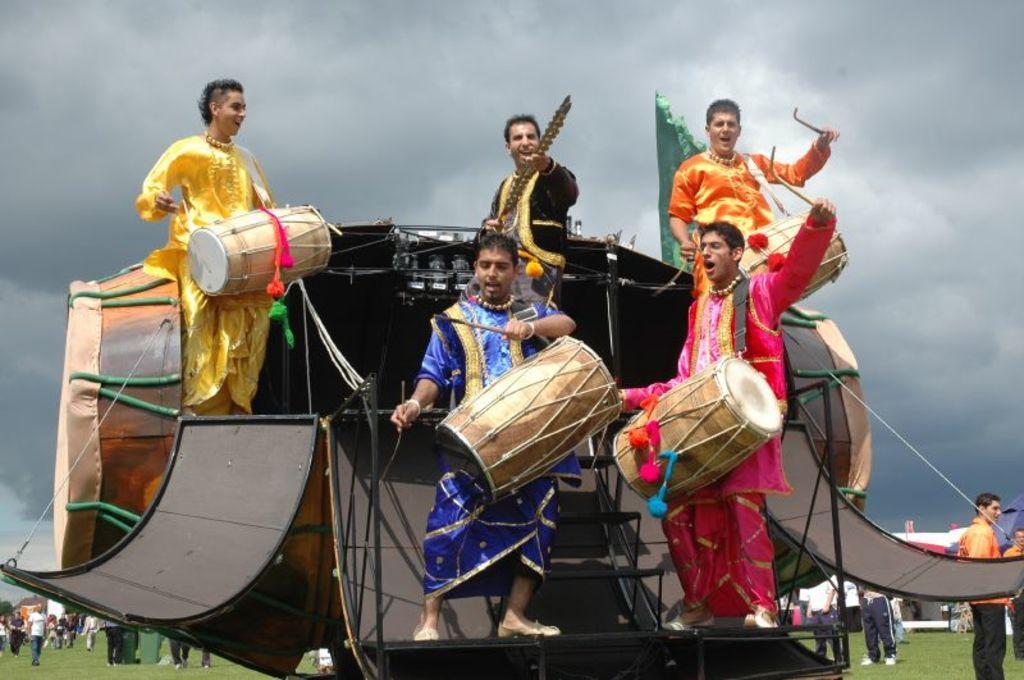Please provide a concise description of this image. In this image I see 5 men who are holding musical instruments in their hands and I see that all of them are wearing different color of dresses and in the background I see number of people and I see the green grass and I see the sky which is cloudy. 